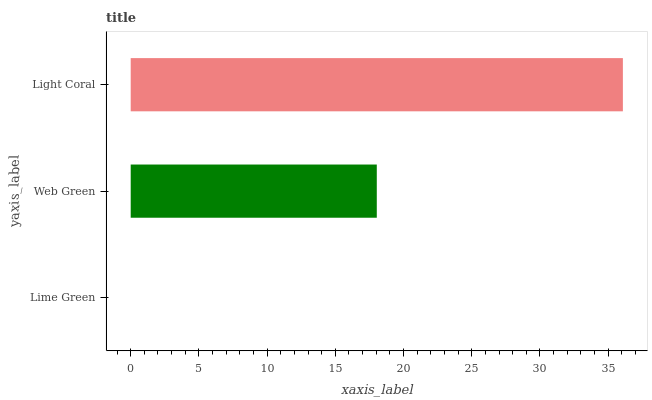Is Lime Green the minimum?
Answer yes or no. Yes. Is Light Coral the maximum?
Answer yes or no. Yes. Is Web Green the minimum?
Answer yes or no. No. Is Web Green the maximum?
Answer yes or no. No. Is Web Green greater than Lime Green?
Answer yes or no. Yes. Is Lime Green less than Web Green?
Answer yes or no. Yes. Is Lime Green greater than Web Green?
Answer yes or no. No. Is Web Green less than Lime Green?
Answer yes or no. No. Is Web Green the high median?
Answer yes or no. Yes. Is Web Green the low median?
Answer yes or no. Yes. Is Lime Green the high median?
Answer yes or no. No. Is Lime Green the low median?
Answer yes or no. No. 